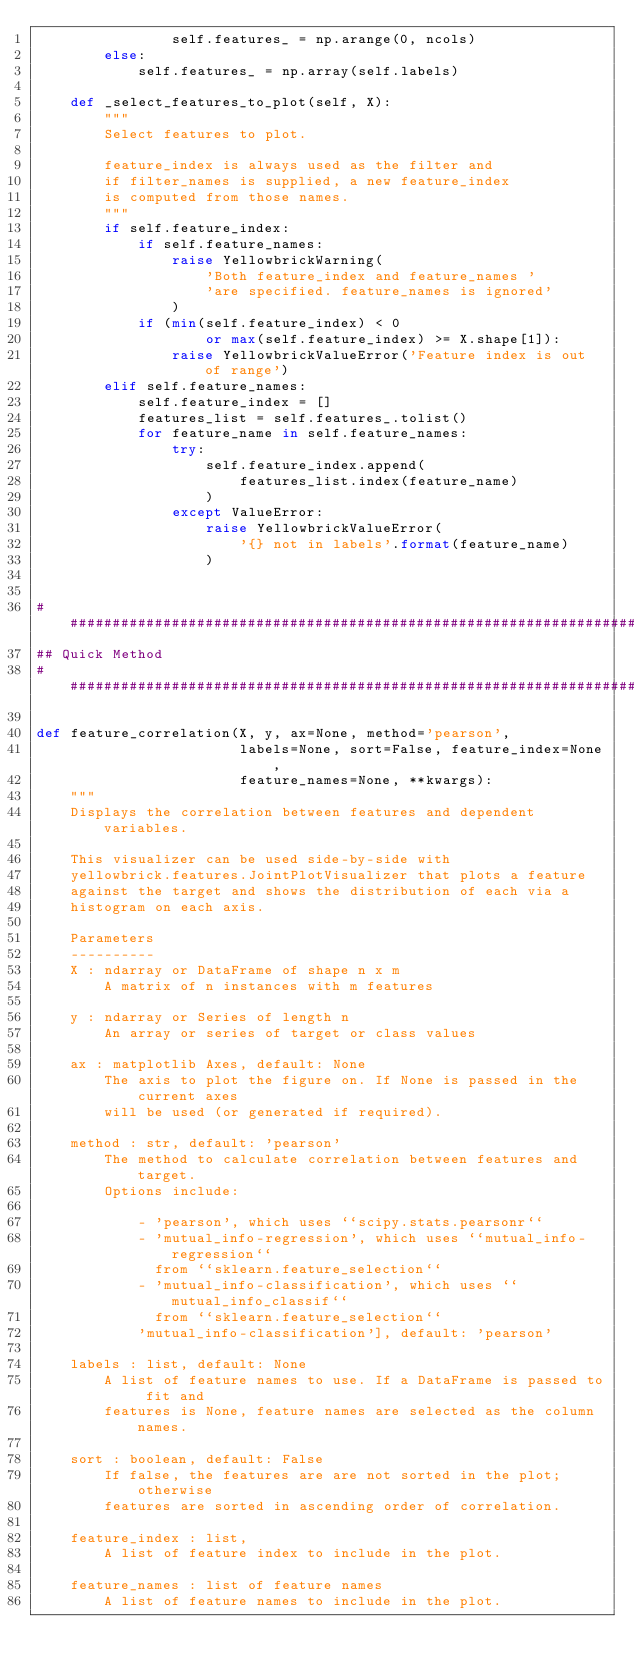Convert code to text. <code><loc_0><loc_0><loc_500><loc_500><_Python_>                self.features_ = np.arange(0, ncols)
        else:
            self.features_ = np.array(self.labels)

    def _select_features_to_plot(self, X):
        """
        Select features to plot.

        feature_index is always used as the filter and
        if filter_names is supplied, a new feature_index
        is computed from those names.
        """
        if self.feature_index:
            if self.feature_names:
                raise YellowbrickWarning(
                    'Both feature_index and feature_names '
                    'are specified. feature_names is ignored'
                )
            if (min(self.feature_index) < 0
                    or max(self.feature_index) >= X.shape[1]):
                raise YellowbrickValueError('Feature index is out of range')
        elif self.feature_names:
            self.feature_index = []
            features_list = self.features_.tolist()
            for feature_name in self.feature_names:
                try:
                    self.feature_index.append(
                        features_list.index(feature_name)
                    )
                except ValueError:
                    raise YellowbrickValueError(
                        '{} not in labels'.format(feature_name)
                    )


##########################################################################
## Quick Method
##########################################################################

def feature_correlation(X, y, ax=None, method='pearson',
                        labels=None, sort=False, feature_index=None,
                        feature_names=None, **kwargs):
    """
    Displays the correlation between features and dependent variables.

    This visualizer can be used side-by-side with
    yellowbrick.features.JointPlotVisualizer that plots a feature
    against the target and shows the distribution of each via a
    histogram on each axis.

    Parameters
    ----------
    X : ndarray or DataFrame of shape n x m
        A matrix of n instances with m features

    y : ndarray or Series of length n
        An array or series of target or class values

    ax : matplotlib Axes, default: None
        The axis to plot the figure on. If None is passed in the current axes
        will be used (or generated if required).

    method : str, default: 'pearson'
        The method to calculate correlation between features and target.
        Options include:

            - 'pearson', which uses ``scipy.stats.pearsonr``
            - 'mutual_info-regression', which uses ``mutual_info-regression``
              from ``sklearn.feature_selection``
            - 'mutual_info-classification', which uses ``mutual_info_classif``
              from ``sklearn.feature_selection``
            'mutual_info-classification'], default: 'pearson'

    labels : list, default: None
        A list of feature names to use. If a DataFrame is passed to fit and
        features is None, feature names are selected as the column names.

    sort : boolean, default: False
        If false, the features are are not sorted in the plot; otherwise
        features are sorted in ascending order of correlation.

    feature_index : list,
        A list of feature index to include in the plot.

    feature_names : list of feature names
        A list of feature names to include in the plot.</code> 